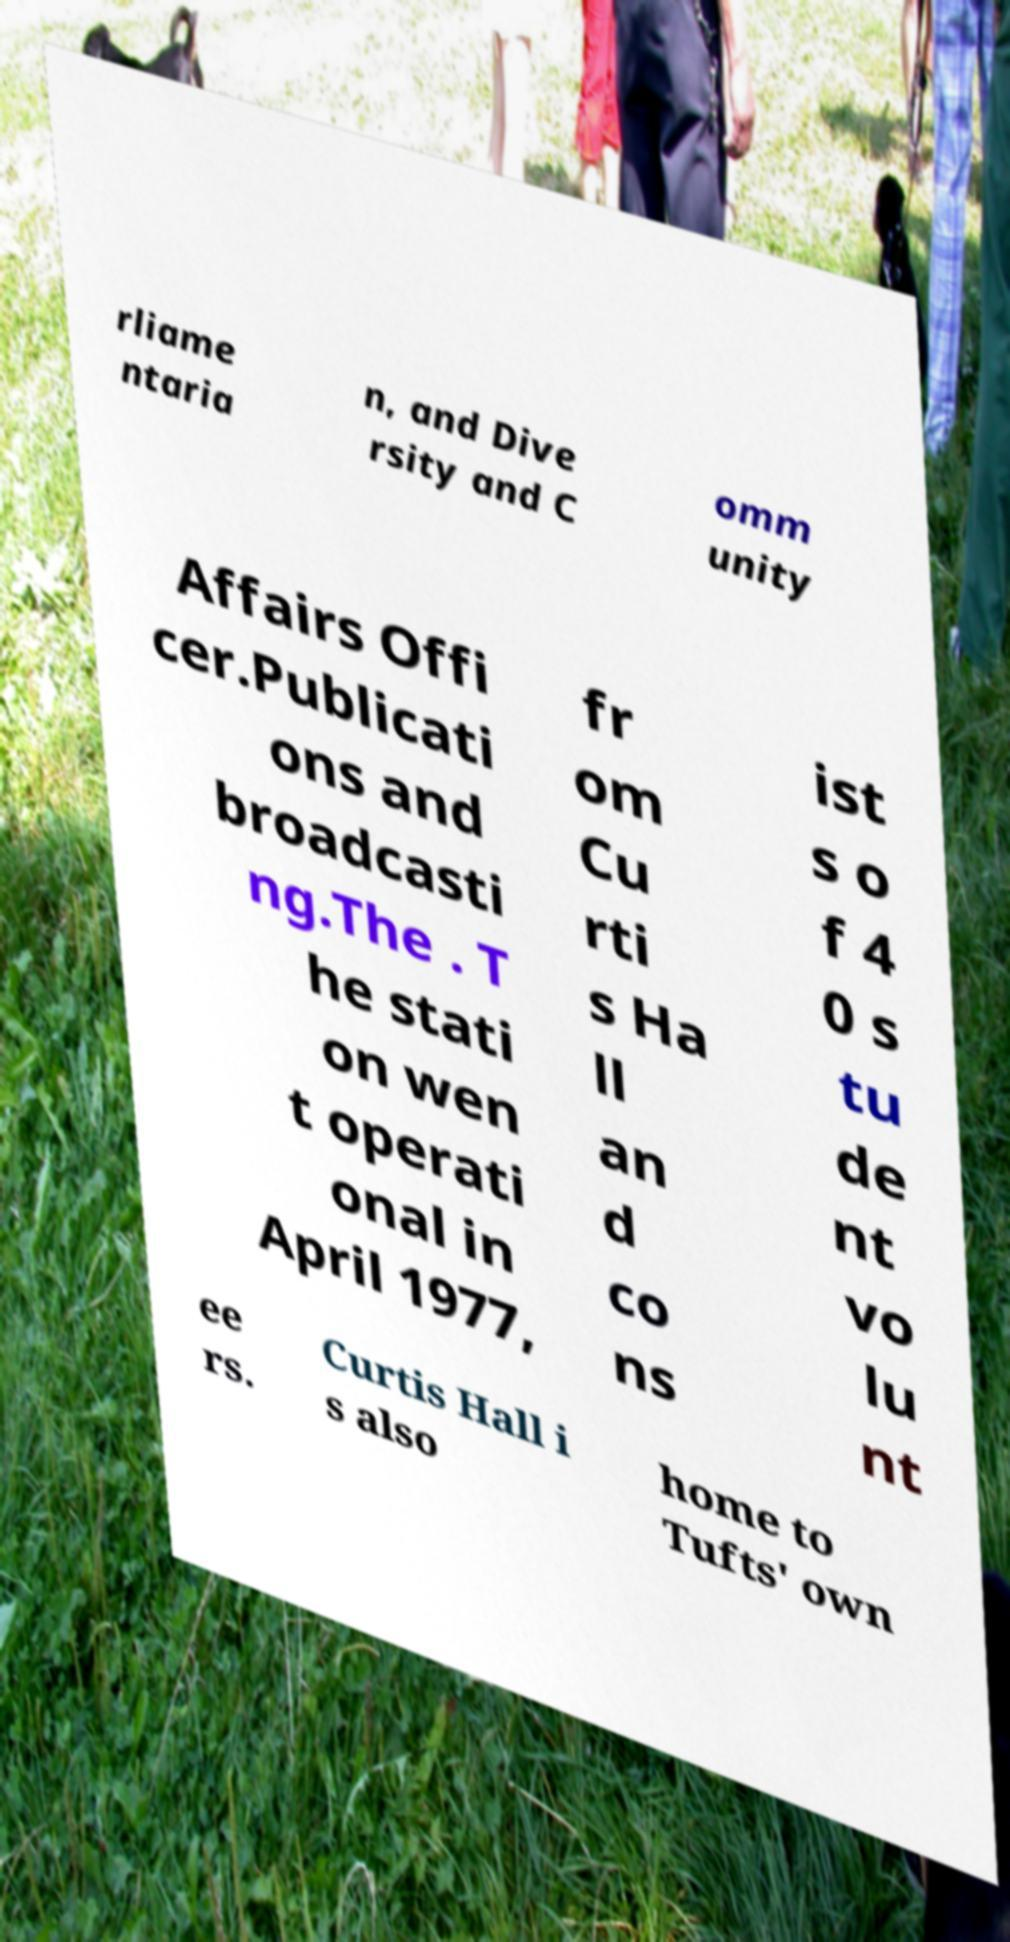What messages or text are displayed in this image? I need them in a readable, typed format. rliame ntaria n, and Dive rsity and C omm unity Affairs Offi cer.Publicati ons and broadcasti ng.The . T he stati on wen t operati onal in April 1977, fr om Cu rti s Ha ll an d co ns ist s o f 4 0 s tu de nt vo lu nt ee rs. Curtis Hall i s also home to Tufts' own 